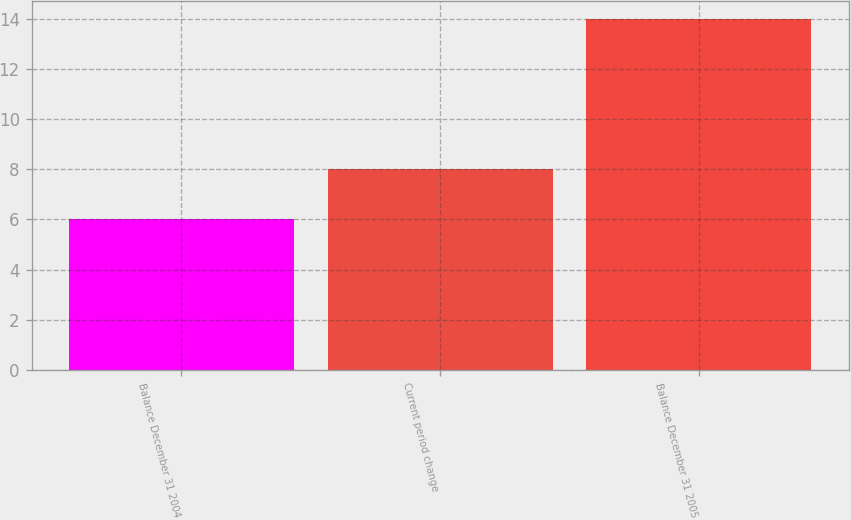Convert chart to OTSL. <chart><loc_0><loc_0><loc_500><loc_500><bar_chart><fcel>Balance December 31 2004<fcel>Current period change<fcel>Balance December 31 2005<nl><fcel>6<fcel>8<fcel>14<nl></chart> 